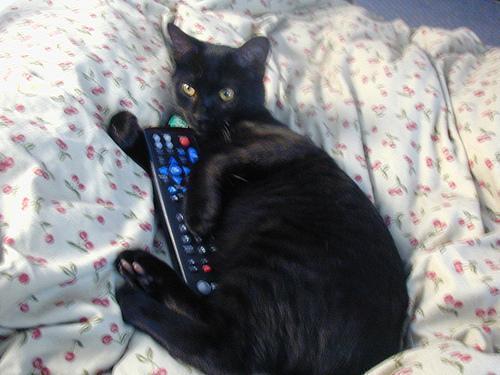What is the cat in control of?
Pick the right solution, then justify: 'Answer: answer
Rationale: rationale.'
Options: Television, car, truck, radio. Answer: television.
Rationale: The controller has many buttons including numbers for changing channels. 